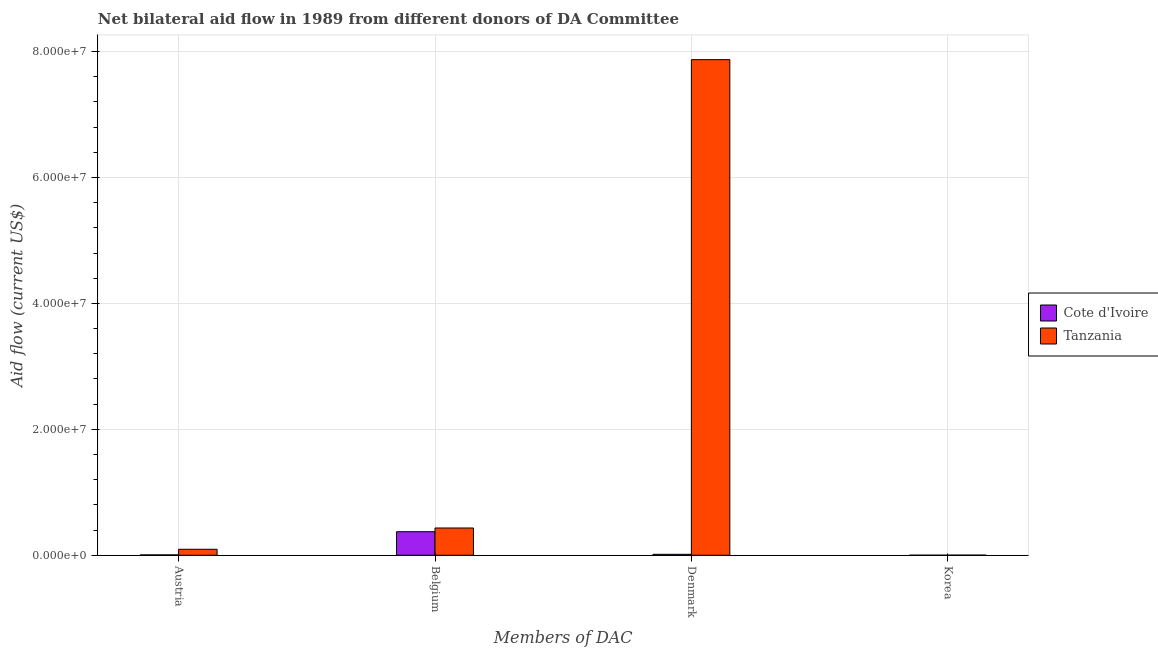Are the number of bars per tick equal to the number of legend labels?
Your response must be concise. Yes. Are the number of bars on each tick of the X-axis equal?
Provide a short and direct response. Yes. How many bars are there on the 3rd tick from the left?
Your answer should be very brief. 2. How many bars are there on the 2nd tick from the right?
Your response must be concise. 2. What is the label of the 2nd group of bars from the left?
Offer a terse response. Belgium. What is the amount of aid given by belgium in Cote d'Ivoire?
Offer a terse response. 3.74e+06. Across all countries, what is the maximum amount of aid given by korea?
Offer a very short reply. 2.00e+04. Across all countries, what is the minimum amount of aid given by austria?
Provide a short and direct response. 6.00e+04. In which country was the amount of aid given by austria maximum?
Offer a terse response. Tanzania. In which country was the amount of aid given by korea minimum?
Provide a succinct answer. Cote d'Ivoire. What is the total amount of aid given by austria in the graph?
Keep it short and to the point. 1.01e+06. What is the difference between the amount of aid given by korea in Cote d'Ivoire and that in Tanzania?
Offer a very short reply. -10000. What is the difference between the amount of aid given by belgium in Cote d'Ivoire and the amount of aid given by austria in Tanzania?
Give a very brief answer. 2.79e+06. What is the average amount of aid given by korea per country?
Make the answer very short. 1.50e+04. What is the difference between the amount of aid given by denmark and amount of aid given by belgium in Cote d'Ivoire?
Make the answer very short. -3.59e+06. In how many countries, is the amount of aid given by austria greater than 8000000 US$?
Ensure brevity in your answer.  0. What is the ratio of the amount of aid given by denmark in Tanzania to that in Cote d'Ivoire?
Provide a succinct answer. 524.8. Is the amount of aid given by denmark in Tanzania less than that in Cote d'Ivoire?
Your response must be concise. No. Is the difference between the amount of aid given by korea in Cote d'Ivoire and Tanzania greater than the difference between the amount of aid given by denmark in Cote d'Ivoire and Tanzania?
Provide a short and direct response. Yes. What is the difference between the highest and the second highest amount of aid given by korea?
Offer a very short reply. 10000. What is the difference between the highest and the lowest amount of aid given by denmark?
Your answer should be compact. 7.86e+07. Is the sum of the amount of aid given by belgium in Cote d'Ivoire and Tanzania greater than the maximum amount of aid given by korea across all countries?
Ensure brevity in your answer.  Yes. What does the 2nd bar from the left in Belgium represents?
Offer a terse response. Tanzania. What does the 1st bar from the right in Belgium represents?
Offer a very short reply. Tanzania. Is it the case that in every country, the sum of the amount of aid given by austria and amount of aid given by belgium is greater than the amount of aid given by denmark?
Keep it short and to the point. No. How many bars are there?
Offer a terse response. 8. Are all the bars in the graph horizontal?
Give a very brief answer. No. How many countries are there in the graph?
Provide a succinct answer. 2. Are the values on the major ticks of Y-axis written in scientific E-notation?
Make the answer very short. Yes. How many legend labels are there?
Your response must be concise. 2. What is the title of the graph?
Your response must be concise. Net bilateral aid flow in 1989 from different donors of DA Committee. Does "Europe(all income levels)" appear as one of the legend labels in the graph?
Keep it short and to the point. No. What is the label or title of the X-axis?
Provide a succinct answer. Members of DAC. What is the label or title of the Y-axis?
Your response must be concise. Aid flow (current US$). What is the Aid flow (current US$) of Tanzania in Austria?
Offer a very short reply. 9.50e+05. What is the Aid flow (current US$) of Cote d'Ivoire in Belgium?
Provide a succinct answer. 3.74e+06. What is the Aid flow (current US$) in Tanzania in Belgium?
Your response must be concise. 4.33e+06. What is the Aid flow (current US$) of Tanzania in Denmark?
Make the answer very short. 7.87e+07. Across all Members of DAC, what is the maximum Aid flow (current US$) of Cote d'Ivoire?
Keep it short and to the point. 3.74e+06. Across all Members of DAC, what is the maximum Aid flow (current US$) of Tanzania?
Make the answer very short. 7.87e+07. Across all Members of DAC, what is the minimum Aid flow (current US$) of Cote d'Ivoire?
Provide a succinct answer. 10000. Across all Members of DAC, what is the minimum Aid flow (current US$) in Tanzania?
Your answer should be very brief. 2.00e+04. What is the total Aid flow (current US$) of Cote d'Ivoire in the graph?
Provide a succinct answer. 3.96e+06. What is the total Aid flow (current US$) in Tanzania in the graph?
Your answer should be compact. 8.40e+07. What is the difference between the Aid flow (current US$) in Cote d'Ivoire in Austria and that in Belgium?
Provide a short and direct response. -3.68e+06. What is the difference between the Aid flow (current US$) of Tanzania in Austria and that in Belgium?
Keep it short and to the point. -3.38e+06. What is the difference between the Aid flow (current US$) of Tanzania in Austria and that in Denmark?
Keep it short and to the point. -7.78e+07. What is the difference between the Aid flow (current US$) in Tanzania in Austria and that in Korea?
Give a very brief answer. 9.30e+05. What is the difference between the Aid flow (current US$) in Cote d'Ivoire in Belgium and that in Denmark?
Your answer should be very brief. 3.59e+06. What is the difference between the Aid flow (current US$) in Tanzania in Belgium and that in Denmark?
Give a very brief answer. -7.44e+07. What is the difference between the Aid flow (current US$) in Cote d'Ivoire in Belgium and that in Korea?
Make the answer very short. 3.73e+06. What is the difference between the Aid flow (current US$) of Tanzania in Belgium and that in Korea?
Make the answer very short. 4.31e+06. What is the difference between the Aid flow (current US$) in Tanzania in Denmark and that in Korea?
Provide a succinct answer. 7.87e+07. What is the difference between the Aid flow (current US$) of Cote d'Ivoire in Austria and the Aid flow (current US$) of Tanzania in Belgium?
Offer a terse response. -4.27e+06. What is the difference between the Aid flow (current US$) of Cote d'Ivoire in Austria and the Aid flow (current US$) of Tanzania in Denmark?
Your answer should be very brief. -7.87e+07. What is the difference between the Aid flow (current US$) in Cote d'Ivoire in Belgium and the Aid flow (current US$) in Tanzania in Denmark?
Ensure brevity in your answer.  -7.50e+07. What is the difference between the Aid flow (current US$) of Cote d'Ivoire in Belgium and the Aid flow (current US$) of Tanzania in Korea?
Provide a short and direct response. 3.72e+06. What is the difference between the Aid flow (current US$) of Cote d'Ivoire in Denmark and the Aid flow (current US$) of Tanzania in Korea?
Provide a succinct answer. 1.30e+05. What is the average Aid flow (current US$) in Cote d'Ivoire per Members of DAC?
Your answer should be very brief. 9.90e+05. What is the average Aid flow (current US$) in Tanzania per Members of DAC?
Ensure brevity in your answer.  2.10e+07. What is the difference between the Aid flow (current US$) in Cote d'Ivoire and Aid flow (current US$) in Tanzania in Austria?
Offer a terse response. -8.90e+05. What is the difference between the Aid flow (current US$) of Cote d'Ivoire and Aid flow (current US$) of Tanzania in Belgium?
Offer a very short reply. -5.90e+05. What is the difference between the Aid flow (current US$) of Cote d'Ivoire and Aid flow (current US$) of Tanzania in Denmark?
Provide a succinct answer. -7.86e+07. What is the difference between the Aid flow (current US$) of Cote d'Ivoire and Aid flow (current US$) of Tanzania in Korea?
Offer a very short reply. -10000. What is the ratio of the Aid flow (current US$) in Cote d'Ivoire in Austria to that in Belgium?
Provide a succinct answer. 0.02. What is the ratio of the Aid flow (current US$) in Tanzania in Austria to that in Belgium?
Make the answer very short. 0.22. What is the ratio of the Aid flow (current US$) of Tanzania in Austria to that in Denmark?
Give a very brief answer. 0.01. What is the ratio of the Aid flow (current US$) in Tanzania in Austria to that in Korea?
Offer a very short reply. 47.5. What is the ratio of the Aid flow (current US$) of Cote d'Ivoire in Belgium to that in Denmark?
Keep it short and to the point. 24.93. What is the ratio of the Aid flow (current US$) of Tanzania in Belgium to that in Denmark?
Give a very brief answer. 0.06. What is the ratio of the Aid flow (current US$) of Cote d'Ivoire in Belgium to that in Korea?
Provide a short and direct response. 374. What is the ratio of the Aid flow (current US$) in Tanzania in Belgium to that in Korea?
Ensure brevity in your answer.  216.5. What is the ratio of the Aid flow (current US$) in Tanzania in Denmark to that in Korea?
Give a very brief answer. 3936. What is the difference between the highest and the second highest Aid flow (current US$) of Cote d'Ivoire?
Make the answer very short. 3.59e+06. What is the difference between the highest and the second highest Aid flow (current US$) in Tanzania?
Your response must be concise. 7.44e+07. What is the difference between the highest and the lowest Aid flow (current US$) in Cote d'Ivoire?
Keep it short and to the point. 3.73e+06. What is the difference between the highest and the lowest Aid flow (current US$) in Tanzania?
Offer a terse response. 7.87e+07. 